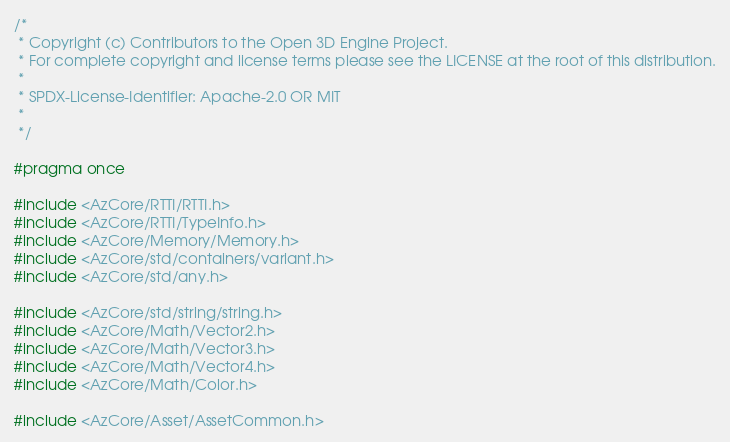<code> <loc_0><loc_0><loc_500><loc_500><_C_>/*
 * Copyright (c) Contributors to the Open 3D Engine Project.
 * For complete copyright and license terms please see the LICENSE at the root of this distribution.
 *
 * SPDX-License-Identifier: Apache-2.0 OR MIT
 *
 */

#pragma once

#include <AzCore/RTTI/RTTI.h>
#include <AzCore/RTTI/TypeInfo.h>
#include <AzCore/Memory/Memory.h>
#include <AzCore/std/containers/variant.h>
#include <AzCore/std/any.h>

#include <AzCore/std/string/string.h>
#include <AzCore/Math/Vector2.h>
#include <AzCore/Math/Vector3.h>
#include <AzCore/Math/Vector4.h>
#include <AzCore/Math/Color.h>

#include <AzCore/Asset/AssetCommon.h></code> 